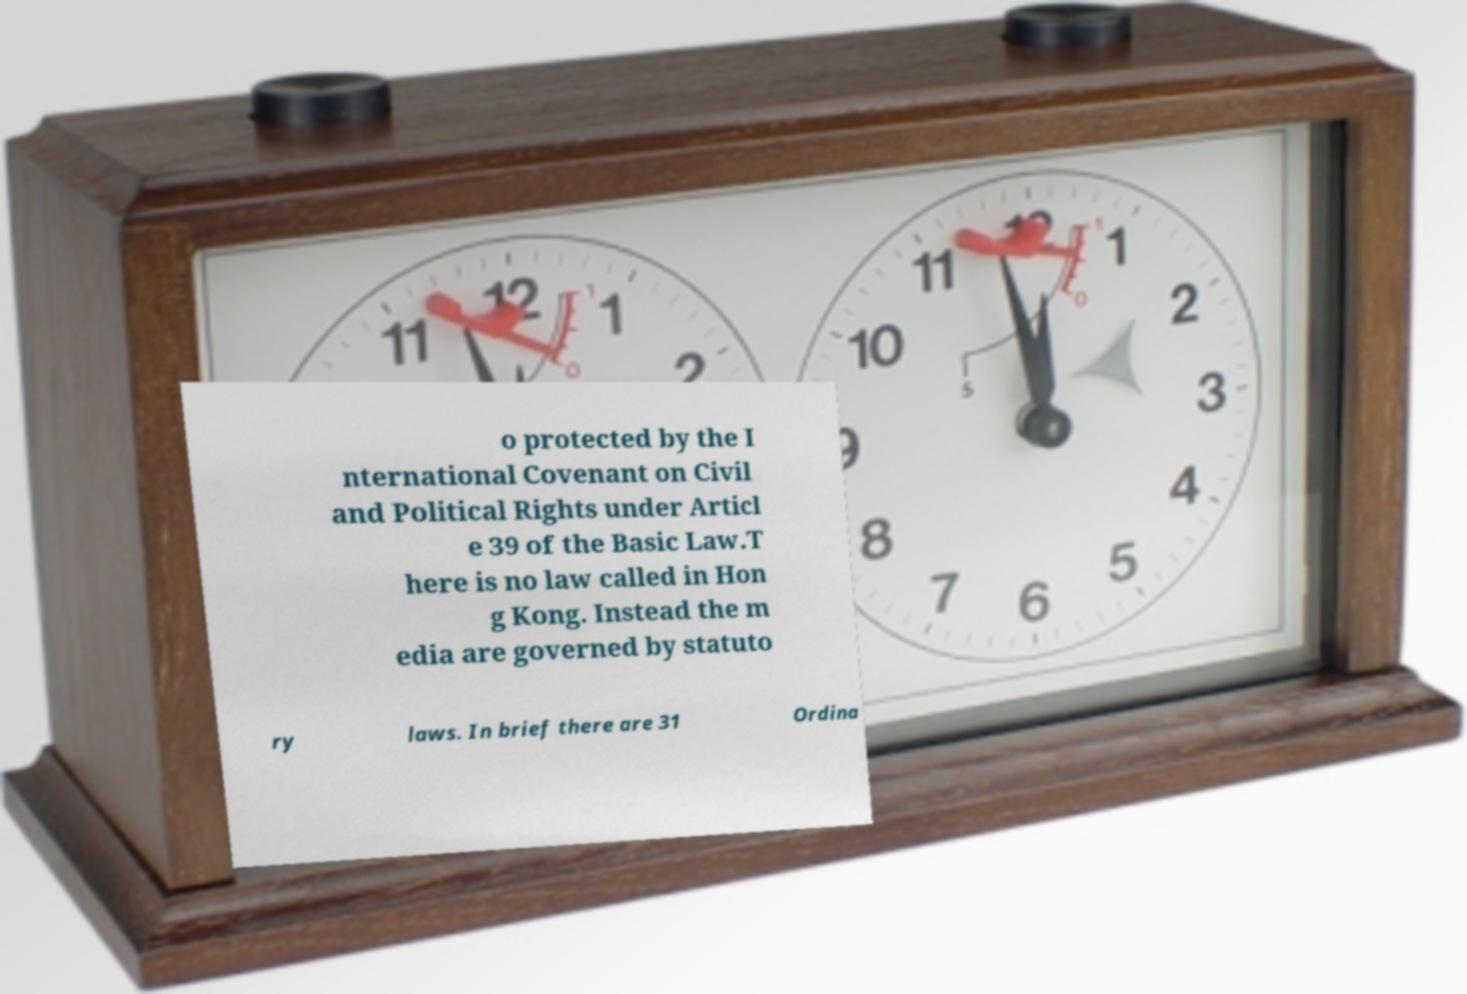Could you assist in decoding the text presented in this image and type it out clearly? o protected by the I nternational Covenant on Civil and Political Rights under Articl e 39 of the Basic Law.T here is no law called in Hon g Kong. Instead the m edia are governed by statuto ry laws. In brief there are 31 Ordina 